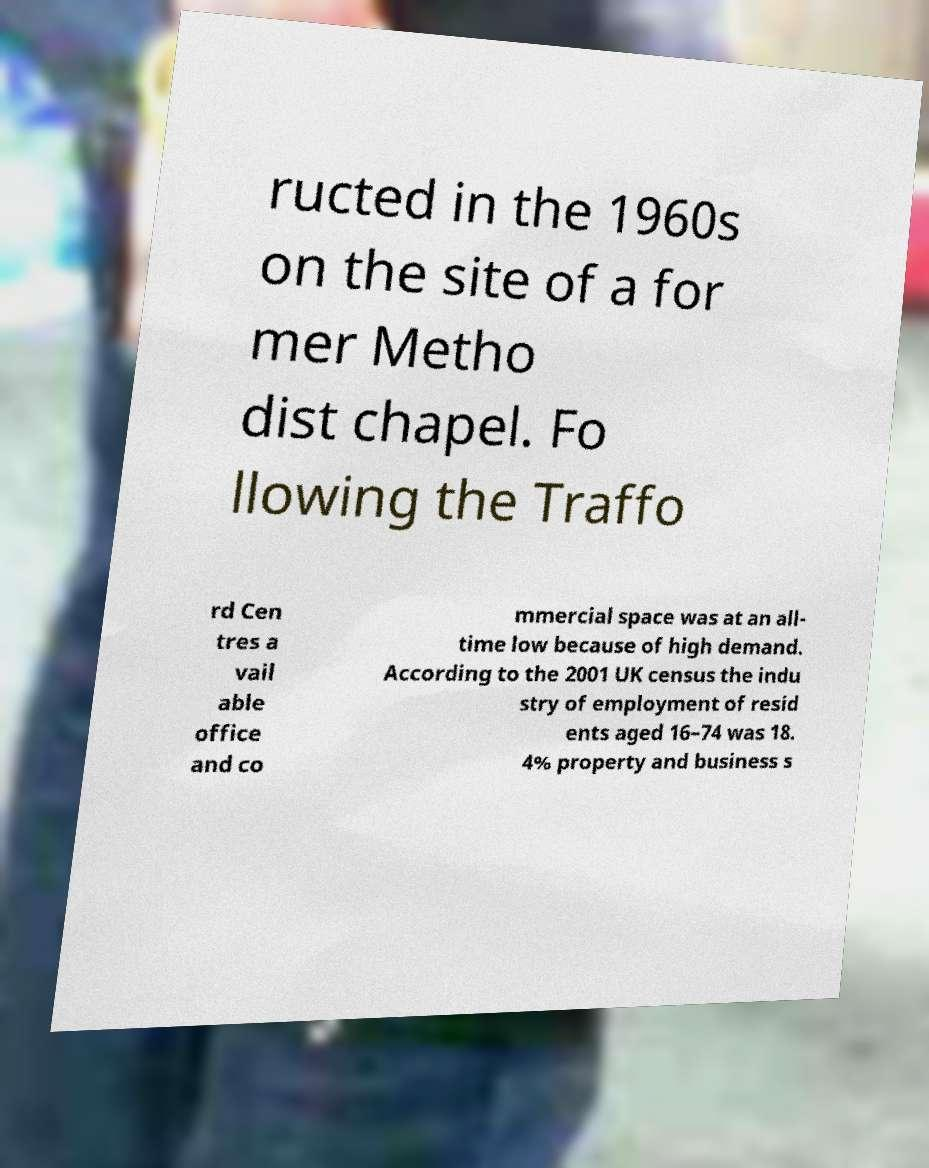What messages or text are displayed in this image? I need them in a readable, typed format. ructed in the 1960s on the site of a for mer Metho dist chapel. Fo llowing the Traffo rd Cen tres a vail able office and co mmercial space was at an all- time low because of high demand. According to the 2001 UK census the indu stry of employment of resid ents aged 16–74 was 18. 4% property and business s 